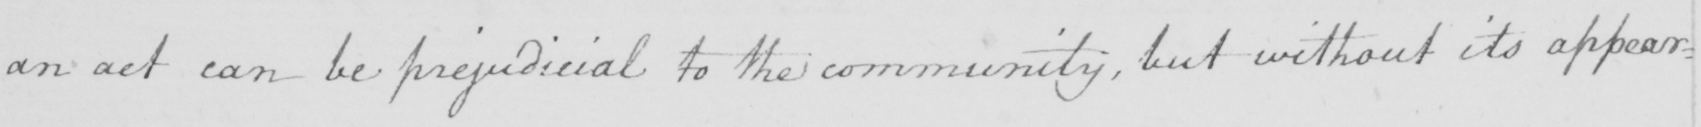Transcribe the text shown in this historical manuscript line. an act can be prejudicial to the community , but without its appear : 